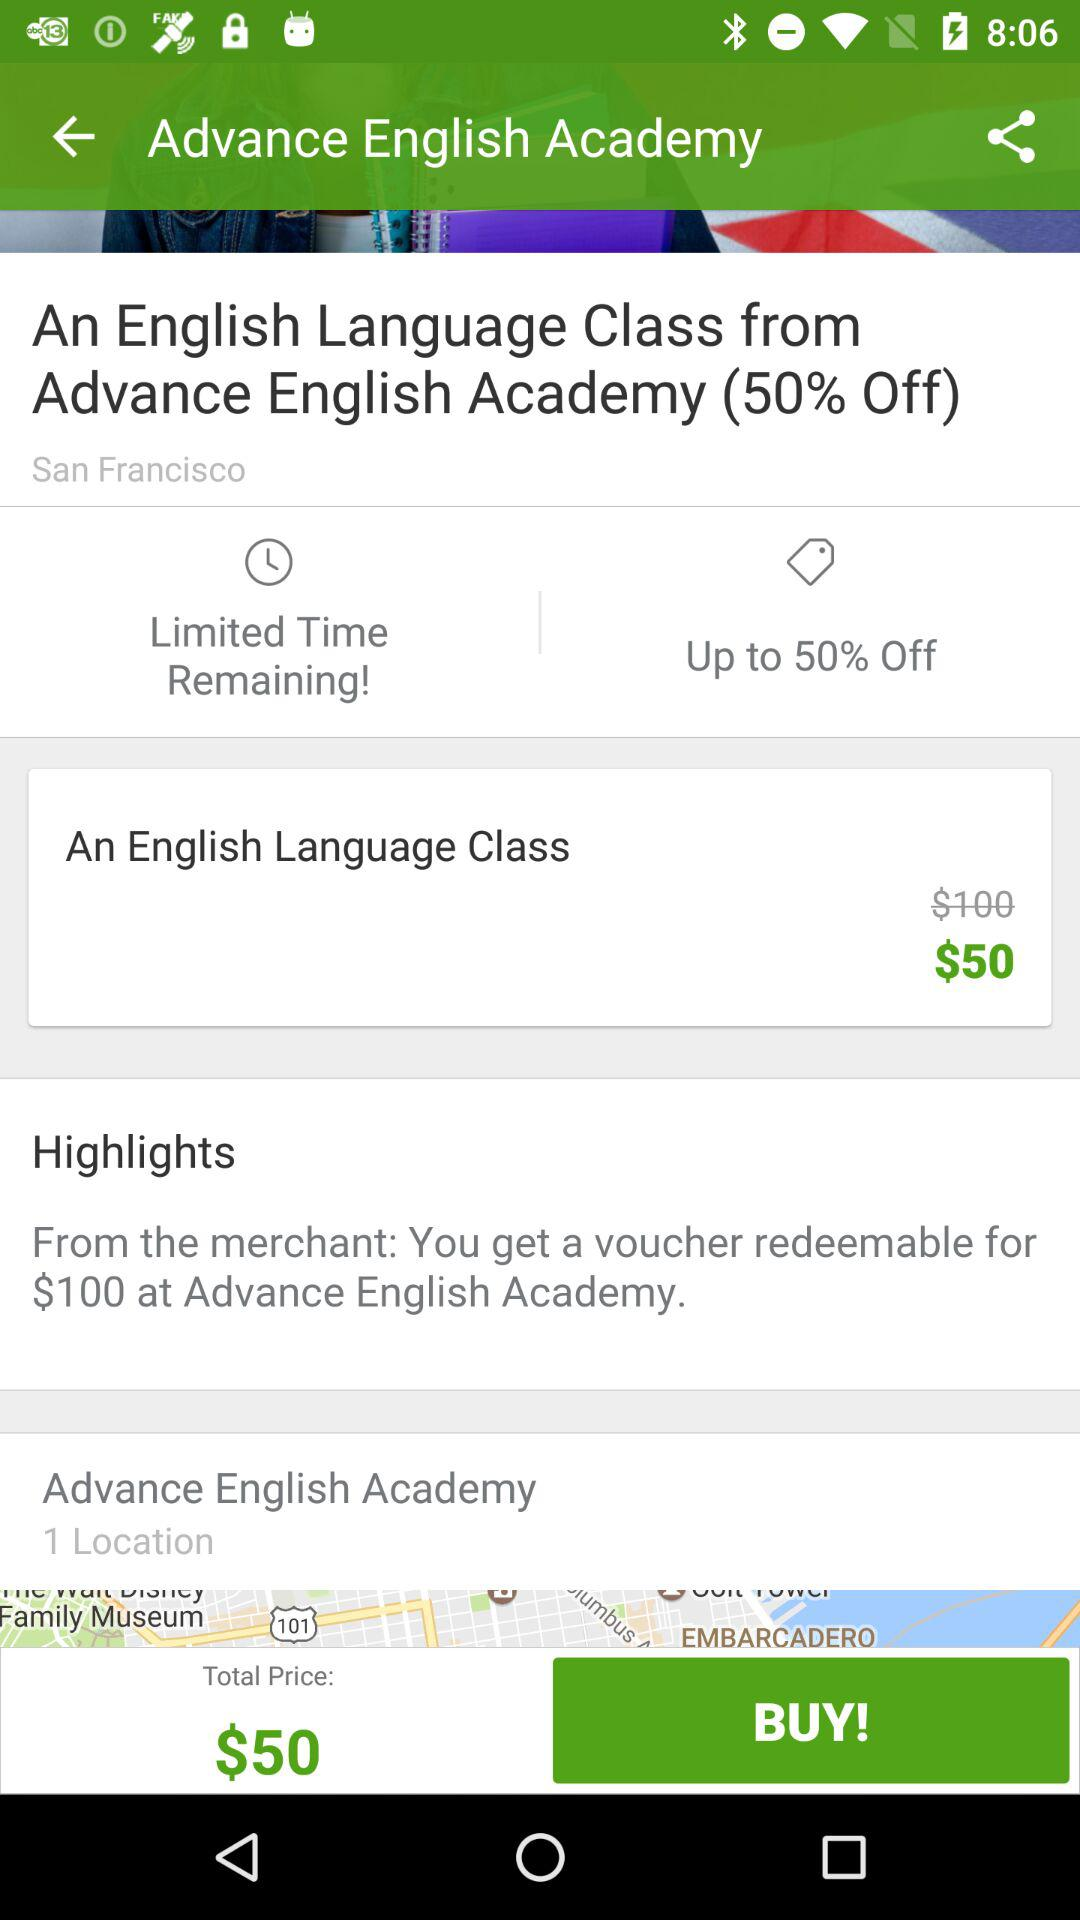How much of a discount is shown here? The shown discount is up to 50% off. 